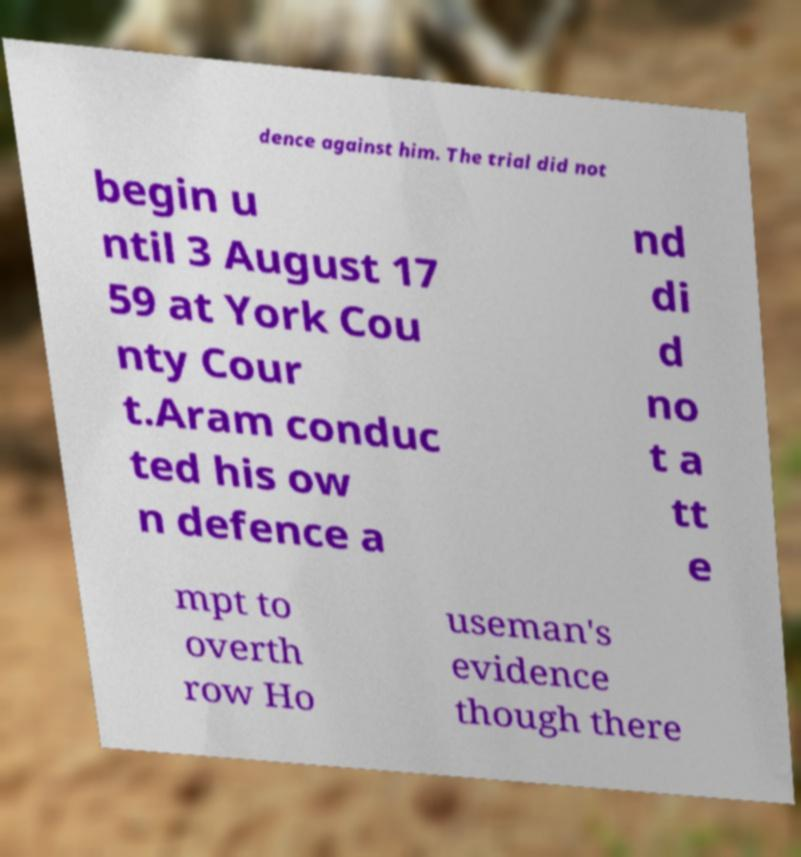Please identify and transcribe the text found in this image. dence against him. The trial did not begin u ntil 3 August 17 59 at York Cou nty Cour t.Aram conduc ted his ow n defence a nd di d no t a tt e mpt to overth row Ho useman's evidence though there 